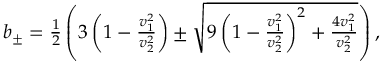Convert formula to latex. <formula><loc_0><loc_0><loc_500><loc_500>\begin{array} { r } { b _ { \pm } = \frac { 1 } { 2 } \left ( 3 \left ( 1 - \frac { v _ { 1 } ^ { 2 } } { v _ { 2 } ^ { 2 } } \right ) \pm \sqrt { 9 \left ( 1 - \frac { v _ { 1 } ^ { 2 } } { v _ { 2 } ^ { 2 } } \right ) ^ { 2 } + \frac { 4 v _ { 1 } ^ { 2 } } { v _ { 2 } ^ { 2 } } } \right ) , } \end{array}</formula> 